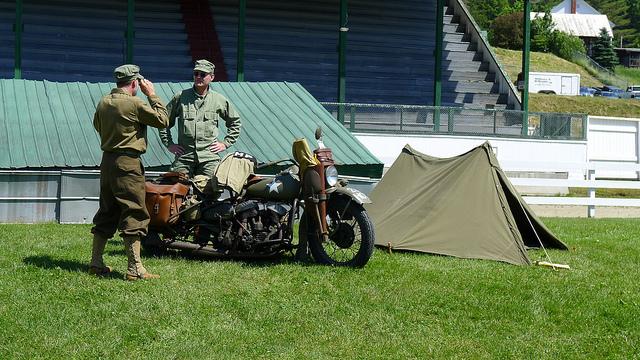What have they pitched on the field?
Keep it brief. Tent. Are they having a conversation?
Write a very short answer. Yes. Are these men in the army?
Write a very short answer. Yes. 